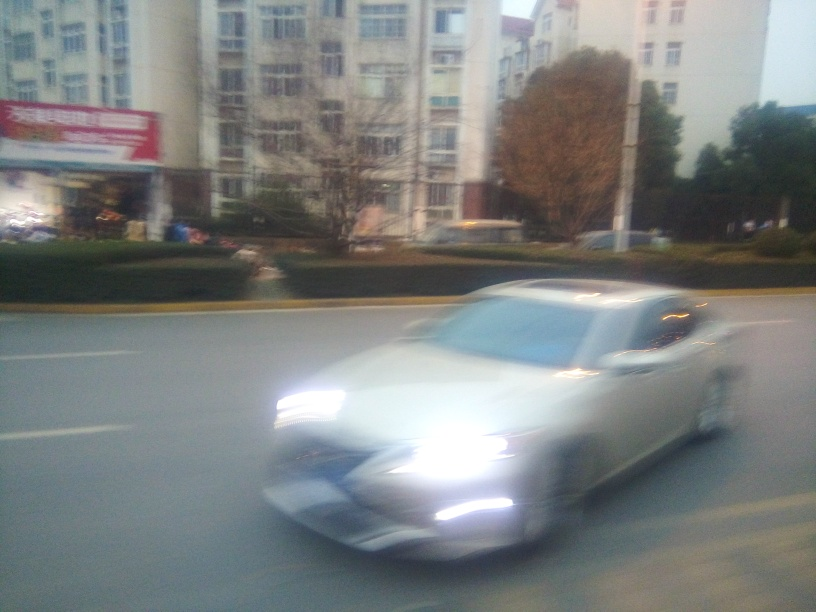What kind of location is shown in this image? This image portrays an urban setting, which can be inferred from the presence of multistory buildings, street lighting, and signage. The signage and architectural style could provide clues as to the specific geographic region, although the blurriness makes it challenging to discern finer details. 